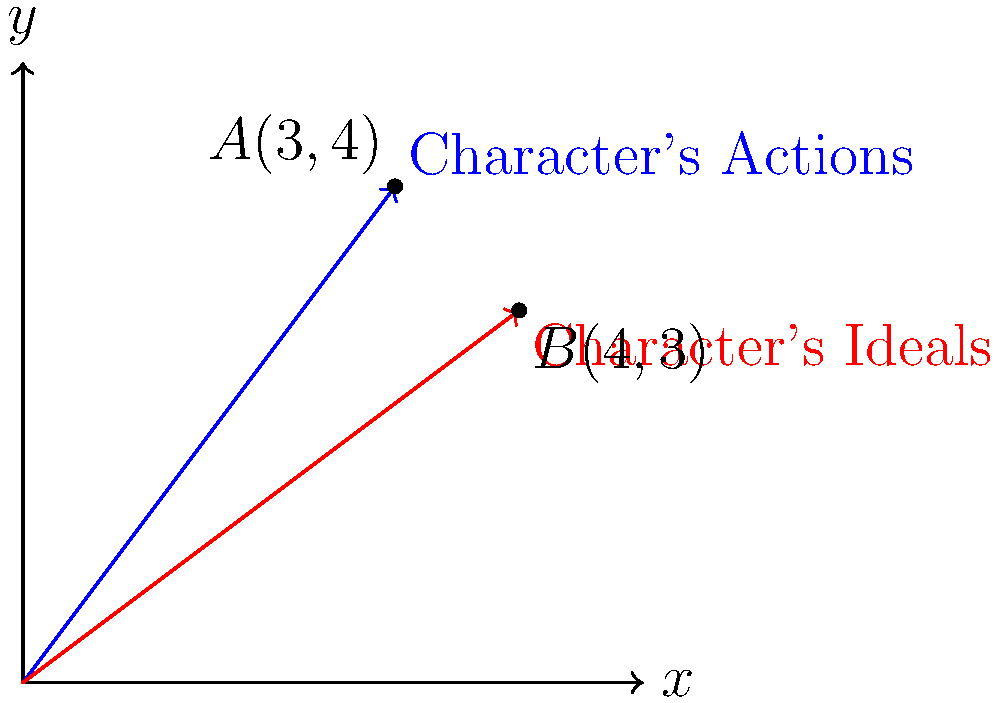In a human rights-themed novel, a character's actions and ideals are represented by vectors $\vec{a} = (3,4)$ and $\vec{b} = (4,3)$ respectively. Calculate the cosine of the angle between these vectors to measure how well the character's actions align with their ideals. Round your answer to three decimal places. To find the cosine of the angle between two vectors using the dot product, we can follow these steps:

1) The formula for the cosine of the angle between two vectors is:
   $$\cos \theta = \frac{\vec{a} \cdot \vec{b}}{|\vec{a}| |\vec{b}|}$$

2) Calculate the dot product $\vec{a} \cdot \vec{b}$:
   $\vec{a} \cdot \vec{b} = (3 \times 4) + (4 \times 3) = 12 + 12 = 24$

3) Calculate the magnitudes of the vectors:
   $|\vec{a}| = \sqrt{3^2 + 4^2} = \sqrt{9 + 16} = \sqrt{25} = 5$
   $|\vec{b}| = \sqrt{4^2 + 3^2} = \sqrt{16 + 9} = \sqrt{25} = 5$

4) Substitute these values into the formula:
   $$\cos \theta = \frac{24}{5 \times 5} = \frac{24}{25} = 0.96$$

5) Round to three decimal places: 0.960

The closer this value is to 1, the more aligned the character's actions are with their ideals. A value of 0.960 indicates a very strong alignment.
Answer: 0.960 